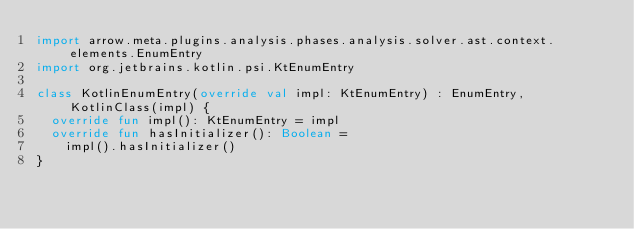<code> <loc_0><loc_0><loc_500><loc_500><_Kotlin_>import arrow.meta.plugins.analysis.phases.analysis.solver.ast.context.elements.EnumEntry
import org.jetbrains.kotlin.psi.KtEnumEntry

class KotlinEnumEntry(override val impl: KtEnumEntry) : EnumEntry, KotlinClass(impl) {
  override fun impl(): KtEnumEntry = impl
  override fun hasInitializer(): Boolean =
    impl().hasInitializer()
}
</code> 